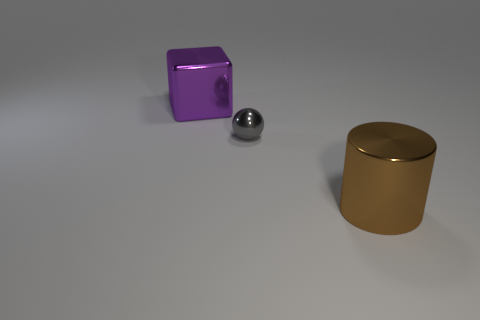Add 3 blue cubes. How many objects exist? 6 Subtract all cubes. How many objects are left? 2 Add 3 brown shiny cylinders. How many brown shiny cylinders exist? 4 Subtract 0 gray cubes. How many objects are left? 3 Subtract all big purple cubes. Subtract all small gray spheres. How many objects are left? 1 Add 1 big cylinders. How many big cylinders are left? 2 